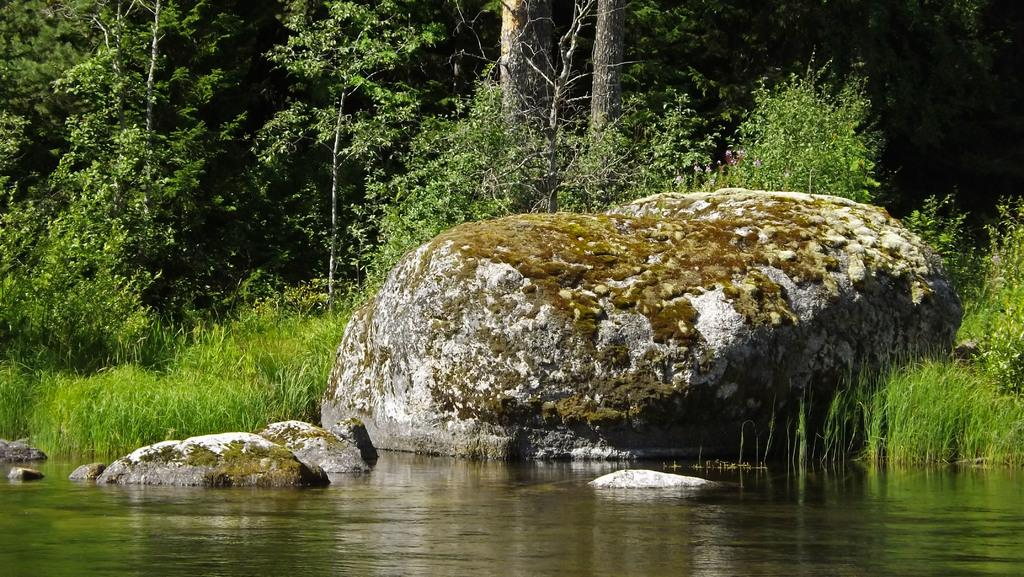What type of natural environment is depicted in the image? The image contains water, grass, trees, and rocks, which are all elements of a natural environment. Can you describe the water in the image? The image contains water, but it doesn't provide any specific details about the water. What type of vegetation is present in the image? There are trees and grass in the image. Are there any man-made structures in the image? No, there are no man-made structures mentioned in the provided facts. What type of knot is tied on the door in the image? There is no door or knot present in the image; it features a natural environment with water, grass, trees, and rocks. 